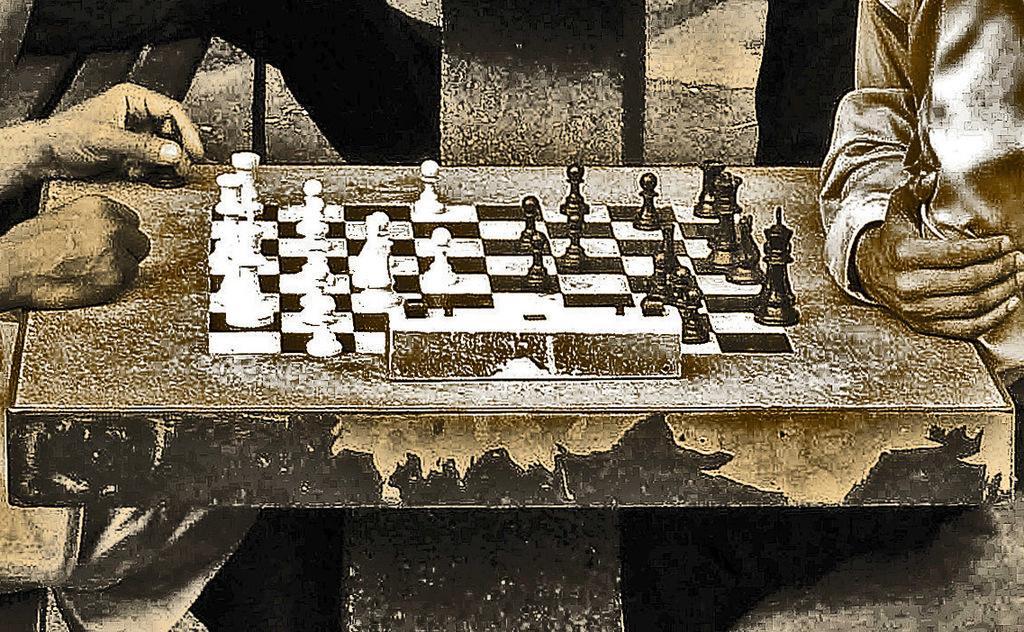Can you describe this image briefly? In this image there is a table, chess board, chess pieces, hands of people and objects.  